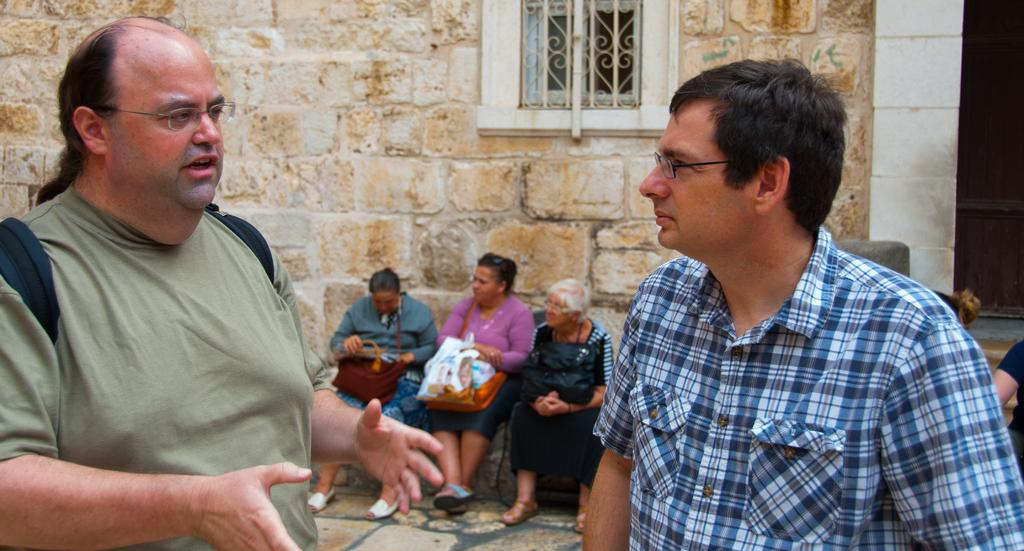How many people are in the image? There are people in the image, but the exact number is not specified. What are the people in the image doing? Some people are sitting, while others are standing. What objects can be seen in the image? Bags are visible in the image. What type of structure is in the image? There is a building in the image. What architectural feature is present in the image? There is a window in the image. How many people in the image are wearing glasses? Two people in the image are wearing glasses (specs). What type of shirt is the plough wearing in the image? There is no plough present in the image, and therefore no shirt to describe. 